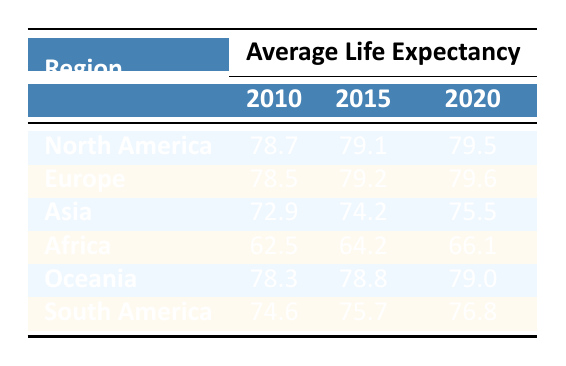What was the average life expectancy in South America in 2020? According to the table, the value listed under South America for the year 2020 is 76.8.
Answer: 76.8 Which region had the highest life expectancy in 2015? By comparing the life expectancies for 2015 across the regions, North America has a value of 79.1, while Europe has 79.2, Asia has 74.2, Africa has 64.2, Oceania has 78.8, and South America has 75.7. Hence, Europe has the highest life expectancy at 79.2.
Answer: Europe What is the average life expectancy for Asia over the years 2010 to 2020? To find the average for Asia, sum the values for 2010 (72.9), 2015 (74.2), and 2020 (75.5). The total is 72.9 + 74.2 + 75.5 = 222.6. Then, divide by 3 (number of years) to get the average, which is 222.6 / 3 = 74.2.
Answer: 74.2 Did Africa's life expectancy increase from 2010 to 2020? Looking at the values, Africa had a life expectancy of 62.5 in 2010 and increased to 66.1 in 2020. Since 66.1 is greater than 62.5, it indicates an increase.
Answer: Yes Which region had the smallest increase in life expectancy from 2010 to 2020? To determine this, calculate the increase for each region: North America (79.5 - 78.7 = 0.8), Europe (79.6 - 78.5 = 1.1), Asia (75.5 - 72.9 = 2.6), Africa (66.1 - 62.5 = 3.6), Oceania (79.0 - 78.3 = 0.7), South America (76.8 - 74.6 = 2.2). Oceania had the smallest increase of 0.7.
Answer: Oceania What percentage increase in life expectancy did Africa experience from 2010 to 2020? The increase in life expectancy for Africa from 2010 (62.5) to 2020 (66.1) is calculated as follows: 66.1 - 62.5 = 3.6. To find the percentage increase, divide the increase by the original value and multiply by 100: (3.6 / 62.5) * 100, which is approximately 5.76%.
Answer: Approximately 5.76% Is it true that North America consistently had the highest average life expectancy each year from 2010 to 2020? From the table, North America's life expectancy was 78.7 in 2010, 79.1 in 2015, and 79.5 in 2020. Comparatively, Europe had 78.5 in 2010, 79.2 in 2015, and 79.6 in 2020. Although North America had the highest in 2010 and 2015, Europe surpassed it in 2020 with 79.6. Hence, the statement is false.
Answer: No What was the difference in average life expectancy between Europe and Oceania in 2015? In 2015, Europe had an average life expectancy of 79.2 and Oceania 78.8. The difference is calculated by subtracting Oceania's value from Europe's: 79.2 - 78.8 = 0.4.
Answer: 0.4 